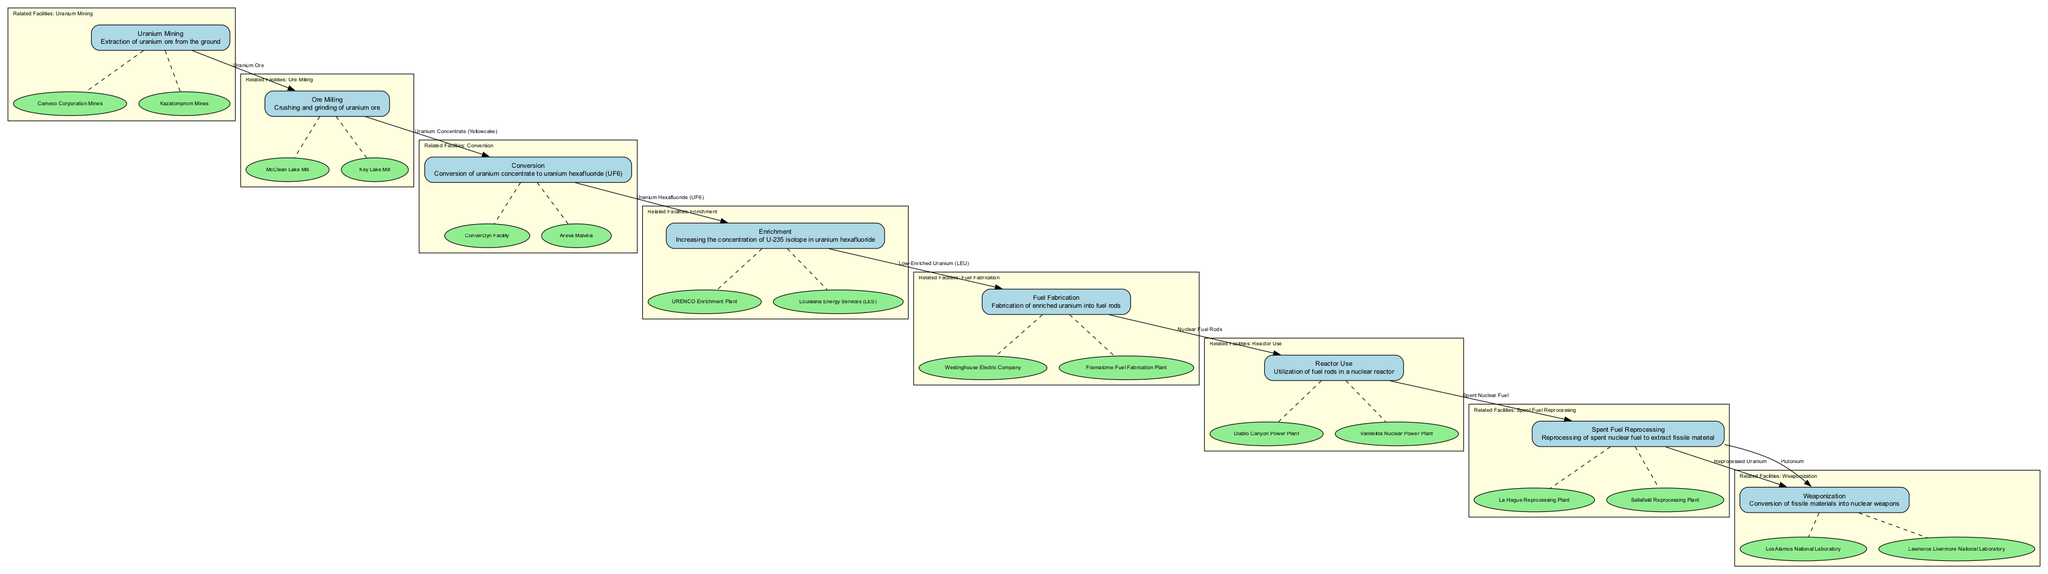What is the first step in the nuclear fuel supply chain? The first step in the nuclear fuel supply chain is Uranium Mining. This is indicated at the top of the diagram where the process begins, with a description associated with it.
Answer: Uranium Mining How many outputs does the Ore Milling process have? The Ore Milling process has one output, which is Uranium Concentrate (Yellowcake). This can be found in the outputs listed for the Ore Milling node in the diagram.
Answer: One Which process transforms Uranium Concentrate into a gas? The process that transforms Uranium Concentrate into a gas is the Conversion process, specifically turning it into Uranium Hexafluoride (UF6). It is directly connected in the flow from Ore Milling to Conversion.
Answer: Conversion What are the outputs of the Enrichment process? The outputs of the Enrichment process are Low-Enriched Uranium (LEU) and Depleted Uranium (DU). These are explicitly listed in the outputs section for the Enrichment node.
Answer: Low-Enriched Uranium (LEU), Depleted Uranium (DU) Which facilities are related to the Fuel Fabrication process? The related facilities to the Fuel Fabrication process are Westinghouse Electric Company and Framatome Fuel Fabrication Plant. These facilities are represented in a subgraph connected to the Fuel Fabrication node.
Answer: Westinghouse Electric Company, Framatome Fuel Fabrication Plant What type of fuel is produced by the Fuel Fabrication process? The type of fuel produced by the Fuel Fabrication process is Nuclear Fuel Rods. This is indicated as the output of the Fuel Fabrication node in the diagram.
Answer: Nuclear Fuel Rods Which two processes produce fissile materials? The two processes that produce fissile materials are Spent Fuel Reprocessing and Weaponization. The Spent Fuel Reprocessing node outputs Reprocessed Uranium and Plutonium, which are inputs for the Weaponization process.
Answer: Spent Fuel Reprocessing, Weaponization How many steps are involved from Uranium Mining to Weaponization? There are a total of eight steps involved from Uranium Mining to Weaponization, including each process outlined in the diagram sequentially leading to the final output.
Answer: Eight What does the Reactor Use process output? The Reactor Use process outputs Spent Nuclear Fuel. This is clearly shown as the output for the Reactor Use node in the diagram.
Answer: Spent Nuclear Fuel What is the relationship between Spent Fuel Reprocessing and Weaponization? The relationship is that Spent Fuel Reprocessing provides the inputs (Reprocessed Uranium and Plutonium) necessary for the Weaponization process to produce Nuclear Weapons. This linkage can be observed through the flow between these two nodes in the diagram.
Answer: Input provision 